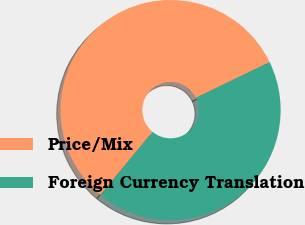Convert chart. <chart><loc_0><loc_0><loc_500><loc_500><pie_chart><fcel>Price/Mix<fcel>Foreign Currency Translation<nl><fcel>56.82%<fcel>43.18%<nl></chart> 